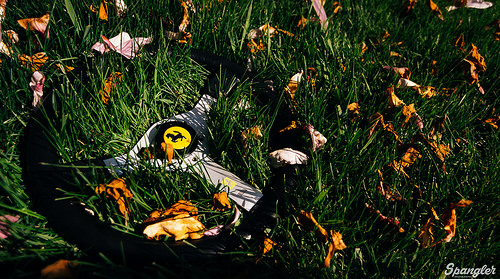<image>
Is there a airplane behind the beach? No. The airplane is not behind the beach. From this viewpoint, the airplane appears to be positioned elsewhere in the scene. 